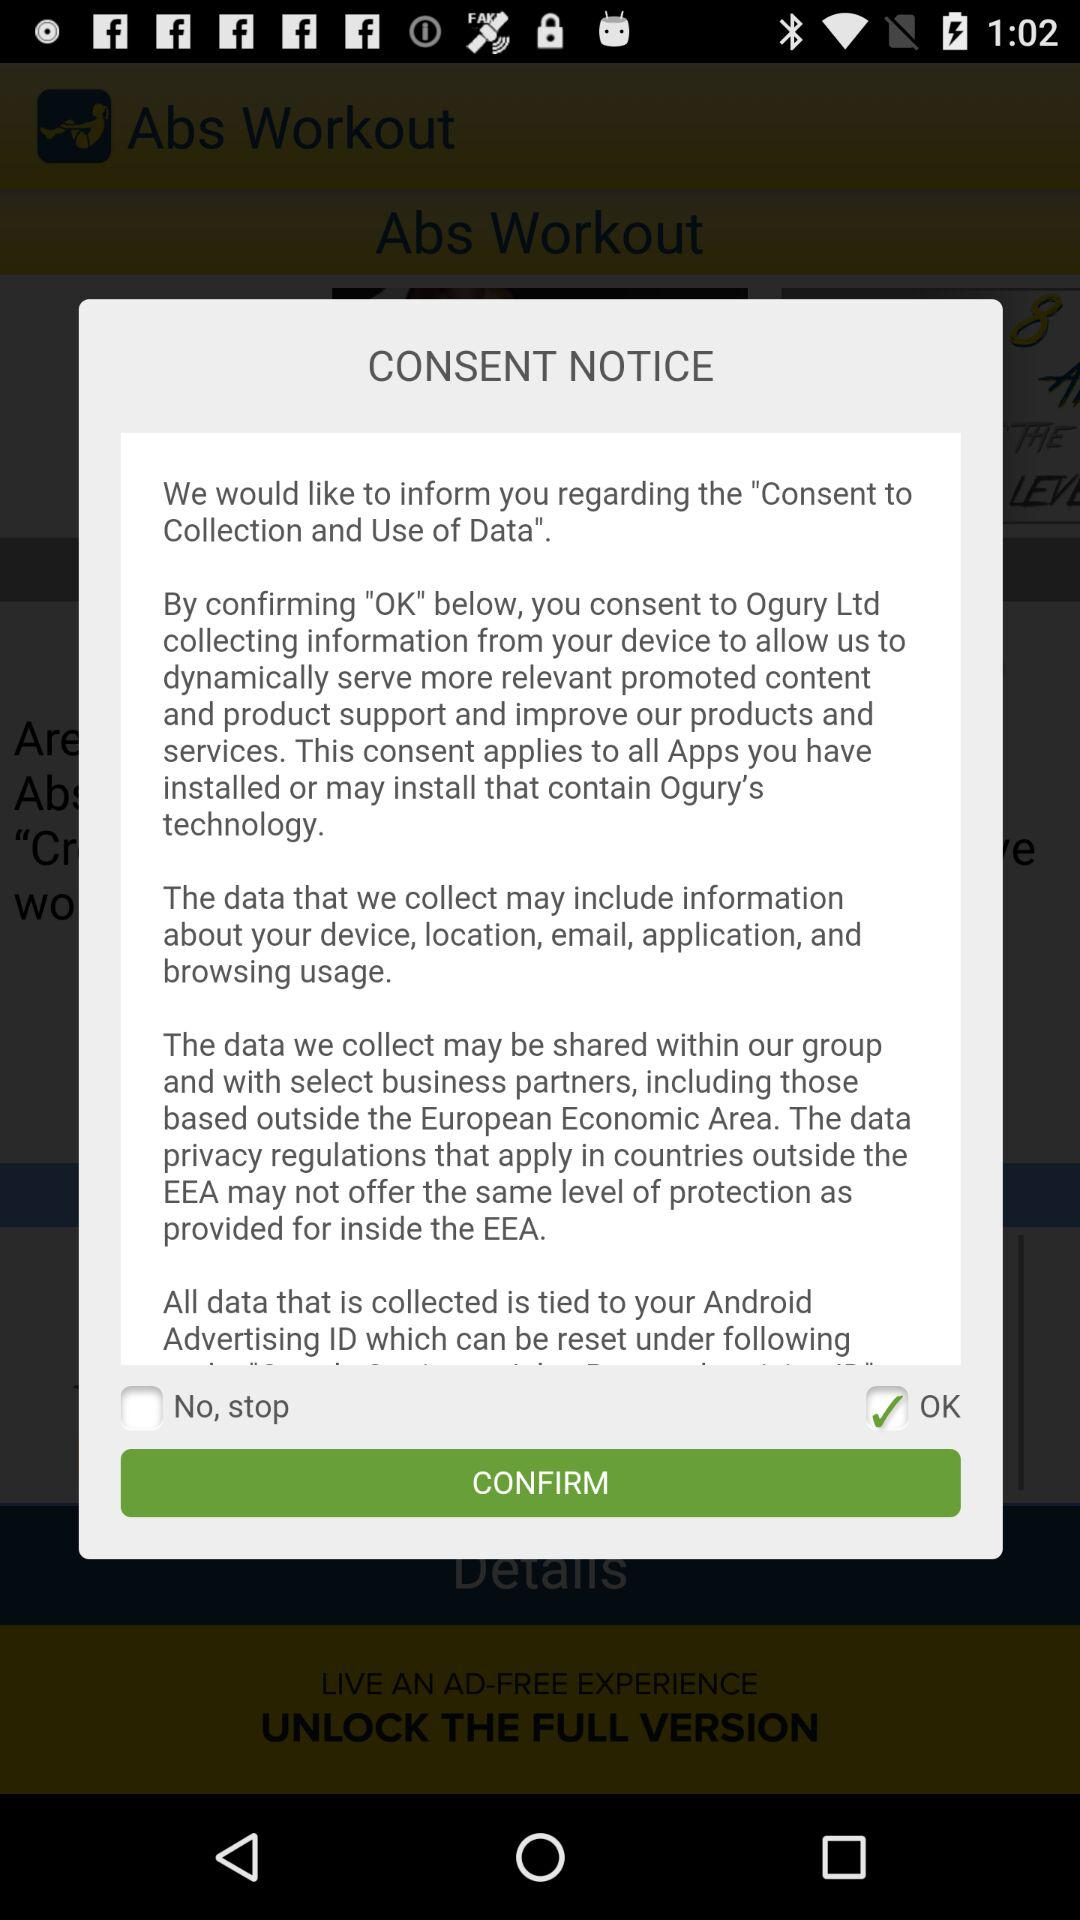What is the status of the no-stop? The status of the no-stop is off. 